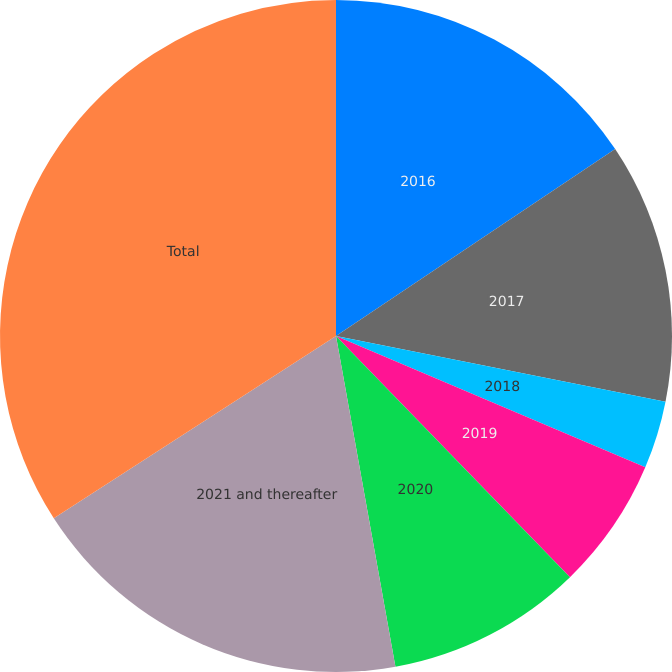Convert chart. <chart><loc_0><loc_0><loc_500><loc_500><pie_chart><fcel>2016<fcel>2017<fcel>2018<fcel>2019<fcel>2020<fcel>2021 and thereafter<fcel>Total<nl><fcel>15.61%<fcel>12.52%<fcel>3.26%<fcel>6.35%<fcel>9.43%<fcel>18.7%<fcel>34.13%<nl></chart> 